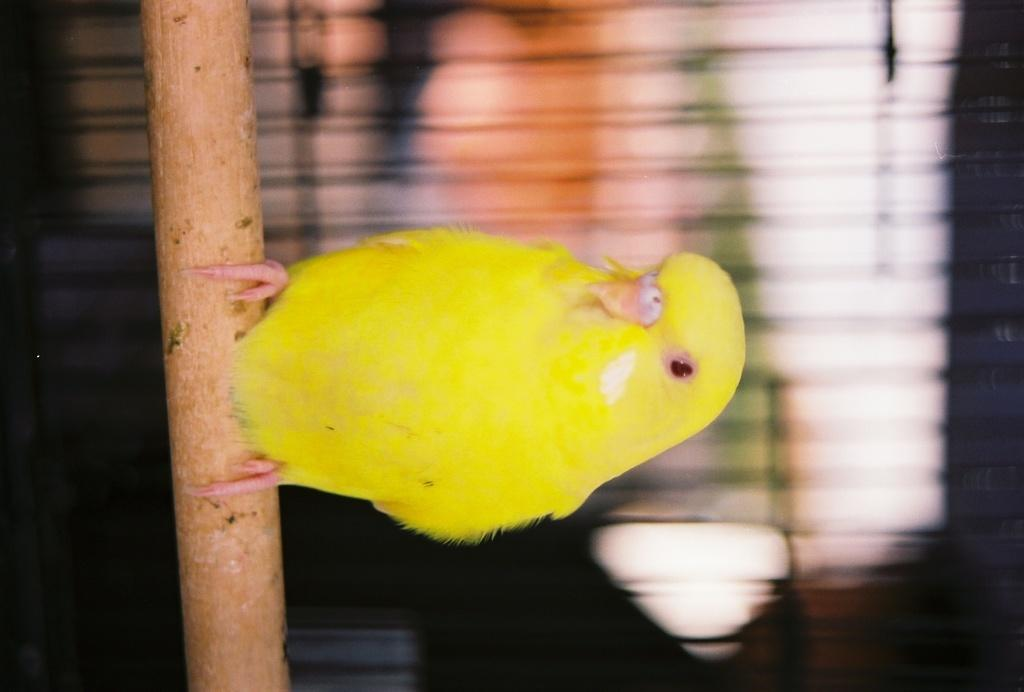What type of animal can be seen in the image? There is a bird in the image. What is the bird standing on? The bird is standing on a tree log. What type of lace is the bird using to fly in the image? There is no lace present in the image, and birds do not use lace to fly. 